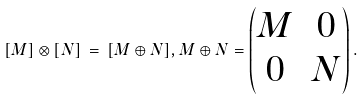Convert formula to latex. <formula><loc_0><loc_0><loc_500><loc_500>[ M ] \otimes [ N ] \, = \, [ M \oplus N ] , M \oplus N = \begin{pmatrix} M & 0 \\ 0 & N \end{pmatrix} .</formula> 